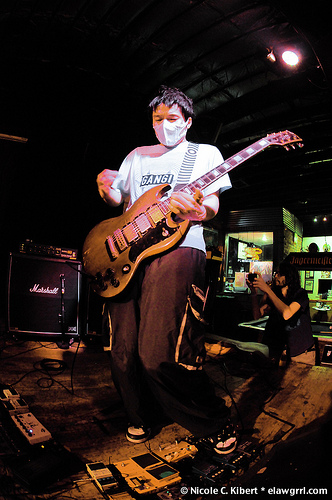<image>
Is the mask under the light? Yes. The mask is positioned underneath the light, with the light above it in the vertical space. Where is the person one in relation to the person two? Is it behind the person two? No. The person one is not behind the person two. From this viewpoint, the person one appears to be positioned elsewhere in the scene. Is the mask in the guitar? No. The mask is not contained within the guitar. These objects have a different spatial relationship. 